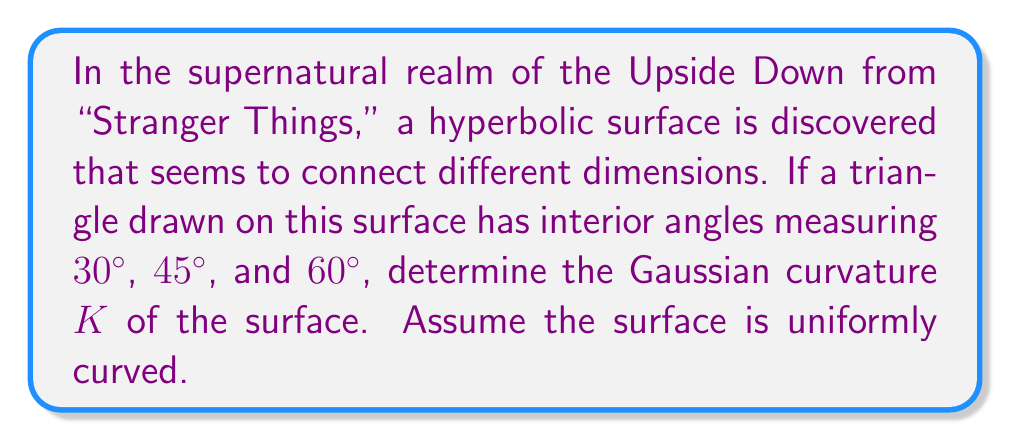What is the answer to this math problem? To solve this problem, we'll follow these steps:

1) In hyperbolic geometry, the sum of the interior angles of a triangle is less than $180°$. The difference between $180°$ and the sum of the angles is related to the area of the triangle and the curvature of the surface.

2) Let's calculate the sum of the given angles:
   $30° + 45° + 60° = 135°$

3) The difference from $180°$ is:
   $180° - 135° = 45° = \frac{\pi}{4}$ radians

4) In hyperbolic geometry, this difference is equal to the area of the triangle multiplied by the negative of the Gaussian curvature. This relationship is given by the Gauss-Bonnet theorem:

   $$ A|K| = \pi - (\alpha + \beta + \gamma) $$

   Where $A$ is the area of the triangle, $K$ is the Gaussian curvature, and $\alpha$, $\beta$, and $\gamma$ are the interior angles.

5) Rearranging this equation:

   $$ |K| = \frac{\pi - (\alpha + \beta + \gamma)}{A} = \frac{\frac{\pi}{4}}{A} $$

6) We don't know the area of the triangle, but we can express the curvature in terms of it:

   $$ K = -\frac{\pi}{4A} $$

   The negative sign is because we're dealing with a hyperbolic surface, which has negative curvature.

7) This expression gives us the Gaussian curvature in terms of the area of the triangle. The smaller the triangle (for a given angle deficit), the more curved the surface.
Answer: $K = -\frac{\pi}{4A}$ 